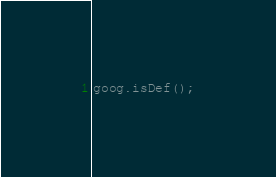<code> <loc_0><loc_0><loc_500><loc_500><_JavaScript_>goog.isDef();
</code> 